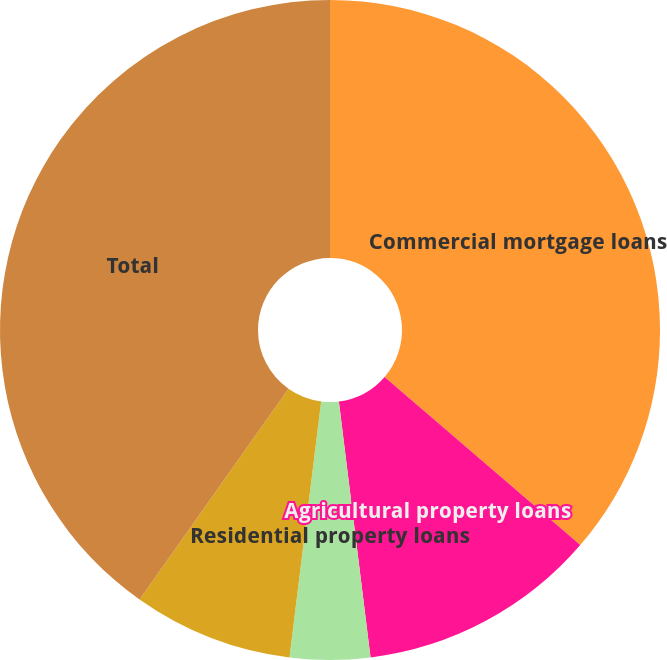<chart> <loc_0><loc_0><loc_500><loc_500><pie_chart><fcel>Commercial mortgage loans<fcel>Agricultural property loans<fcel>Residential property loans<fcel>Other collateralized loans<fcel>Uncollateralized loans<fcel>Total<nl><fcel>36.3%<fcel>11.74%<fcel>3.92%<fcel>0.0%<fcel>7.83%<fcel>40.21%<nl></chart> 